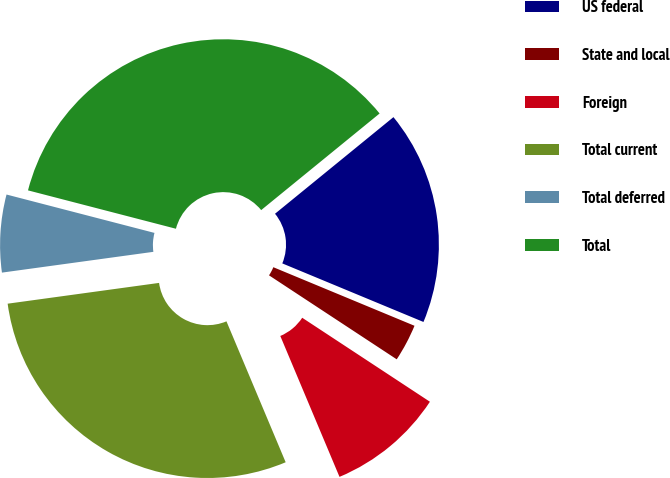<chart> <loc_0><loc_0><loc_500><loc_500><pie_chart><fcel>US federal<fcel>State and local<fcel>Foreign<fcel>Total current<fcel>Total deferred<fcel>Total<nl><fcel>17.15%<fcel>3.0%<fcel>9.41%<fcel>29.16%<fcel>6.21%<fcel>35.07%<nl></chart> 